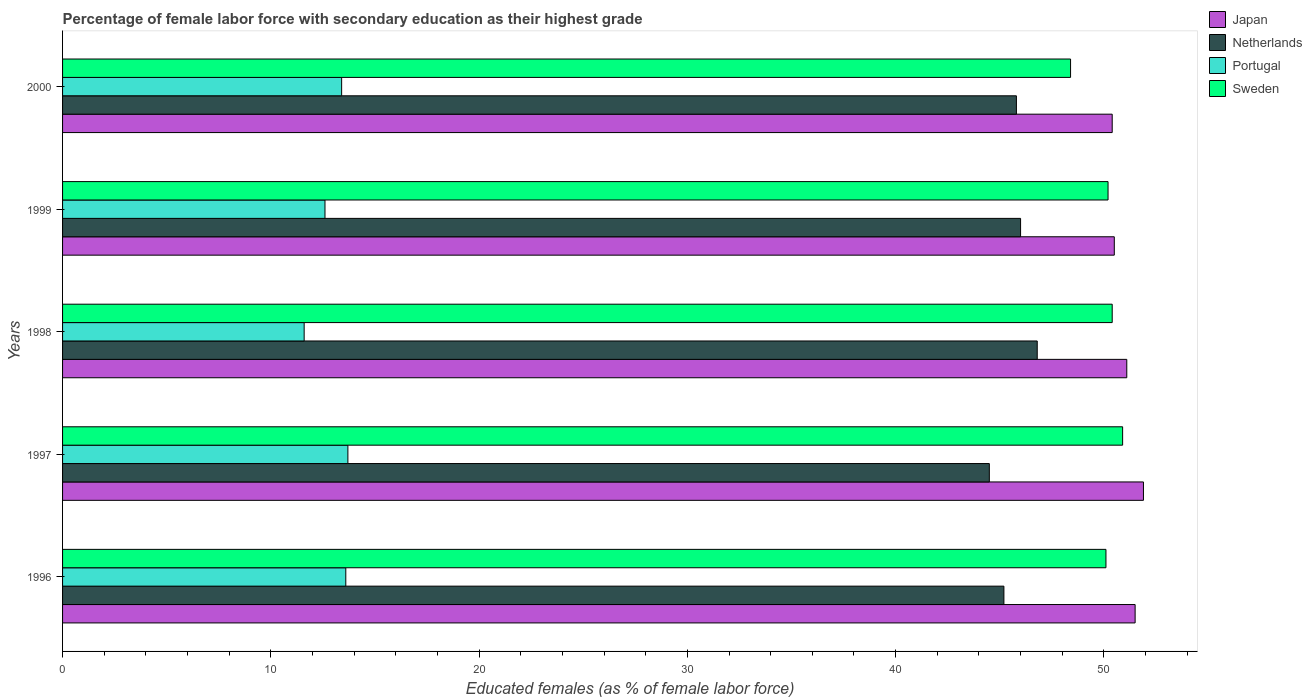How many different coloured bars are there?
Your answer should be very brief. 4. How many groups of bars are there?
Offer a terse response. 5. What is the label of the 4th group of bars from the top?
Your answer should be compact. 1997. What is the percentage of female labor force with secondary education in Sweden in 1998?
Keep it short and to the point. 50.4. Across all years, what is the maximum percentage of female labor force with secondary education in Sweden?
Ensure brevity in your answer.  50.9. Across all years, what is the minimum percentage of female labor force with secondary education in Portugal?
Offer a terse response. 11.6. In which year was the percentage of female labor force with secondary education in Portugal maximum?
Your answer should be compact. 1997. In which year was the percentage of female labor force with secondary education in Portugal minimum?
Make the answer very short. 1998. What is the total percentage of female labor force with secondary education in Japan in the graph?
Your answer should be very brief. 255.4. What is the difference between the percentage of female labor force with secondary education in Netherlands in 1997 and that in 2000?
Offer a terse response. -1.3. What is the difference between the percentage of female labor force with secondary education in Netherlands in 1996 and the percentage of female labor force with secondary education in Sweden in 1999?
Your answer should be compact. -5. What is the average percentage of female labor force with secondary education in Sweden per year?
Keep it short and to the point. 50. In the year 2000, what is the difference between the percentage of female labor force with secondary education in Portugal and percentage of female labor force with secondary education in Sweden?
Ensure brevity in your answer.  -35. In how many years, is the percentage of female labor force with secondary education in Portugal greater than 38 %?
Make the answer very short. 0. What is the ratio of the percentage of female labor force with secondary education in Portugal in 1997 to that in 2000?
Your answer should be compact. 1.02. What is the difference between the highest and the second highest percentage of female labor force with secondary education in Netherlands?
Make the answer very short. 0.8. What is the difference between the highest and the lowest percentage of female labor force with secondary education in Sweden?
Make the answer very short. 2.5. In how many years, is the percentage of female labor force with secondary education in Portugal greater than the average percentage of female labor force with secondary education in Portugal taken over all years?
Your response must be concise. 3. Is it the case that in every year, the sum of the percentage of female labor force with secondary education in Japan and percentage of female labor force with secondary education in Portugal is greater than the sum of percentage of female labor force with secondary education in Sweden and percentage of female labor force with secondary education in Netherlands?
Your answer should be compact. No. Is it the case that in every year, the sum of the percentage of female labor force with secondary education in Portugal and percentage of female labor force with secondary education in Japan is greater than the percentage of female labor force with secondary education in Sweden?
Give a very brief answer. Yes. Are all the bars in the graph horizontal?
Keep it short and to the point. Yes. How many years are there in the graph?
Your response must be concise. 5. Are the values on the major ticks of X-axis written in scientific E-notation?
Your response must be concise. No. Does the graph contain grids?
Your response must be concise. No. How many legend labels are there?
Keep it short and to the point. 4. How are the legend labels stacked?
Provide a succinct answer. Vertical. What is the title of the graph?
Provide a succinct answer. Percentage of female labor force with secondary education as their highest grade. What is the label or title of the X-axis?
Keep it short and to the point. Educated females (as % of female labor force). What is the label or title of the Y-axis?
Offer a terse response. Years. What is the Educated females (as % of female labor force) of Japan in 1996?
Give a very brief answer. 51.5. What is the Educated females (as % of female labor force) of Netherlands in 1996?
Make the answer very short. 45.2. What is the Educated females (as % of female labor force) in Portugal in 1996?
Your response must be concise. 13.6. What is the Educated females (as % of female labor force) in Sweden in 1996?
Offer a terse response. 50.1. What is the Educated females (as % of female labor force) of Japan in 1997?
Give a very brief answer. 51.9. What is the Educated females (as % of female labor force) of Netherlands in 1997?
Give a very brief answer. 44.5. What is the Educated females (as % of female labor force) in Portugal in 1997?
Your answer should be compact. 13.7. What is the Educated females (as % of female labor force) of Sweden in 1997?
Provide a succinct answer. 50.9. What is the Educated females (as % of female labor force) in Japan in 1998?
Provide a succinct answer. 51.1. What is the Educated females (as % of female labor force) in Netherlands in 1998?
Your response must be concise. 46.8. What is the Educated females (as % of female labor force) in Portugal in 1998?
Your response must be concise. 11.6. What is the Educated females (as % of female labor force) of Sweden in 1998?
Make the answer very short. 50.4. What is the Educated females (as % of female labor force) of Japan in 1999?
Keep it short and to the point. 50.5. What is the Educated females (as % of female labor force) of Portugal in 1999?
Your answer should be compact. 12.6. What is the Educated females (as % of female labor force) of Sweden in 1999?
Your answer should be very brief. 50.2. What is the Educated females (as % of female labor force) of Japan in 2000?
Your response must be concise. 50.4. What is the Educated females (as % of female labor force) of Netherlands in 2000?
Ensure brevity in your answer.  45.8. What is the Educated females (as % of female labor force) in Portugal in 2000?
Make the answer very short. 13.4. What is the Educated females (as % of female labor force) in Sweden in 2000?
Your answer should be compact. 48.4. Across all years, what is the maximum Educated females (as % of female labor force) in Japan?
Offer a terse response. 51.9. Across all years, what is the maximum Educated females (as % of female labor force) of Netherlands?
Provide a short and direct response. 46.8. Across all years, what is the maximum Educated females (as % of female labor force) of Portugal?
Offer a very short reply. 13.7. Across all years, what is the maximum Educated females (as % of female labor force) of Sweden?
Make the answer very short. 50.9. Across all years, what is the minimum Educated females (as % of female labor force) of Japan?
Your response must be concise. 50.4. Across all years, what is the minimum Educated females (as % of female labor force) in Netherlands?
Ensure brevity in your answer.  44.5. Across all years, what is the minimum Educated females (as % of female labor force) of Portugal?
Offer a very short reply. 11.6. Across all years, what is the minimum Educated females (as % of female labor force) of Sweden?
Offer a very short reply. 48.4. What is the total Educated females (as % of female labor force) of Japan in the graph?
Give a very brief answer. 255.4. What is the total Educated females (as % of female labor force) of Netherlands in the graph?
Your answer should be very brief. 228.3. What is the total Educated females (as % of female labor force) of Portugal in the graph?
Offer a very short reply. 64.9. What is the total Educated females (as % of female labor force) in Sweden in the graph?
Ensure brevity in your answer.  250. What is the difference between the Educated females (as % of female labor force) in Japan in 1996 and that in 1997?
Keep it short and to the point. -0.4. What is the difference between the Educated females (as % of female labor force) of Netherlands in 1996 and that in 1997?
Make the answer very short. 0.7. What is the difference between the Educated females (as % of female labor force) in Sweden in 1996 and that in 1997?
Give a very brief answer. -0.8. What is the difference between the Educated females (as % of female labor force) of Netherlands in 1996 and that in 1998?
Provide a succinct answer. -1.6. What is the difference between the Educated females (as % of female labor force) in Portugal in 1996 and that in 1998?
Your response must be concise. 2. What is the difference between the Educated females (as % of female labor force) in Sweden in 1996 and that in 1998?
Offer a very short reply. -0.3. What is the difference between the Educated females (as % of female labor force) in Netherlands in 1996 and that in 1999?
Offer a terse response. -0.8. What is the difference between the Educated females (as % of female labor force) of Portugal in 1996 and that in 2000?
Your answer should be compact. 0.2. What is the difference between the Educated females (as % of female labor force) in Sweden in 1996 and that in 2000?
Your answer should be very brief. 1.7. What is the difference between the Educated females (as % of female labor force) in Japan in 1997 and that in 1998?
Your answer should be very brief. 0.8. What is the difference between the Educated females (as % of female labor force) of Netherlands in 1997 and that in 1998?
Provide a succinct answer. -2.3. What is the difference between the Educated females (as % of female labor force) in Portugal in 1997 and that in 1998?
Keep it short and to the point. 2.1. What is the difference between the Educated females (as % of female labor force) in Japan in 1997 and that in 1999?
Ensure brevity in your answer.  1.4. What is the difference between the Educated females (as % of female labor force) of Netherlands in 1997 and that in 1999?
Offer a terse response. -1.5. What is the difference between the Educated females (as % of female labor force) of Portugal in 1997 and that in 1999?
Your answer should be compact. 1.1. What is the difference between the Educated females (as % of female labor force) of Sweden in 1997 and that in 1999?
Offer a terse response. 0.7. What is the difference between the Educated females (as % of female labor force) in Netherlands in 1997 and that in 2000?
Make the answer very short. -1.3. What is the difference between the Educated females (as % of female labor force) of Netherlands in 1998 and that in 1999?
Your response must be concise. 0.8. What is the difference between the Educated females (as % of female labor force) of Japan in 1998 and that in 2000?
Your response must be concise. 0.7. What is the difference between the Educated females (as % of female labor force) in Portugal in 1998 and that in 2000?
Your answer should be compact. -1.8. What is the difference between the Educated females (as % of female labor force) in Sweden in 1998 and that in 2000?
Offer a terse response. 2. What is the difference between the Educated females (as % of female labor force) of Netherlands in 1999 and that in 2000?
Your answer should be very brief. 0.2. What is the difference between the Educated females (as % of female labor force) of Japan in 1996 and the Educated females (as % of female labor force) of Portugal in 1997?
Your answer should be compact. 37.8. What is the difference between the Educated females (as % of female labor force) of Netherlands in 1996 and the Educated females (as % of female labor force) of Portugal in 1997?
Keep it short and to the point. 31.5. What is the difference between the Educated females (as % of female labor force) of Netherlands in 1996 and the Educated females (as % of female labor force) of Sweden in 1997?
Offer a very short reply. -5.7. What is the difference between the Educated females (as % of female labor force) of Portugal in 1996 and the Educated females (as % of female labor force) of Sweden in 1997?
Keep it short and to the point. -37.3. What is the difference between the Educated females (as % of female labor force) in Japan in 1996 and the Educated females (as % of female labor force) in Portugal in 1998?
Keep it short and to the point. 39.9. What is the difference between the Educated females (as % of female labor force) in Netherlands in 1996 and the Educated females (as % of female labor force) in Portugal in 1998?
Offer a very short reply. 33.6. What is the difference between the Educated females (as % of female labor force) in Portugal in 1996 and the Educated females (as % of female labor force) in Sweden in 1998?
Your answer should be very brief. -36.8. What is the difference between the Educated females (as % of female labor force) in Japan in 1996 and the Educated females (as % of female labor force) in Portugal in 1999?
Offer a terse response. 38.9. What is the difference between the Educated females (as % of female labor force) of Japan in 1996 and the Educated females (as % of female labor force) of Sweden in 1999?
Offer a very short reply. 1.3. What is the difference between the Educated females (as % of female labor force) of Netherlands in 1996 and the Educated females (as % of female labor force) of Portugal in 1999?
Keep it short and to the point. 32.6. What is the difference between the Educated females (as % of female labor force) of Portugal in 1996 and the Educated females (as % of female labor force) of Sweden in 1999?
Give a very brief answer. -36.6. What is the difference between the Educated females (as % of female labor force) of Japan in 1996 and the Educated females (as % of female labor force) of Netherlands in 2000?
Offer a very short reply. 5.7. What is the difference between the Educated females (as % of female labor force) of Japan in 1996 and the Educated females (as % of female labor force) of Portugal in 2000?
Your response must be concise. 38.1. What is the difference between the Educated females (as % of female labor force) of Netherlands in 1996 and the Educated females (as % of female labor force) of Portugal in 2000?
Offer a terse response. 31.8. What is the difference between the Educated females (as % of female labor force) of Netherlands in 1996 and the Educated females (as % of female labor force) of Sweden in 2000?
Your answer should be very brief. -3.2. What is the difference between the Educated females (as % of female labor force) in Portugal in 1996 and the Educated females (as % of female labor force) in Sweden in 2000?
Offer a very short reply. -34.8. What is the difference between the Educated females (as % of female labor force) of Japan in 1997 and the Educated females (as % of female labor force) of Netherlands in 1998?
Provide a short and direct response. 5.1. What is the difference between the Educated females (as % of female labor force) of Japan in 1997 and the Educated females (as % of female labor force) of Portugal in 1998?
Keep it short and to the point. 40.3. What is the difference between the Educated females (as % of female labor force) in Japan in 1997 and the Educated females (as % of female labor force) in Sweden in 1998?
Your answer should be compact. 1.5. What is the difference between the Educated females (as % of female labor force) of Netherlands in 1997 and the Educated females (as % of female labor force) of Portugal in 1998?
Ensure brevity in your answer.  32.9. What is the difference between the Educated females (as % of female labor force) of Portugal in 1997 and the Educated females (as % of female labor force) of Sweden in 1998?
Keep it short and to the point. -36.7. What is the difference between the Educated females (as % of female labor force) in Japan in 1997 and the Educated females (as % of female labor force) in Netherlands in 1999?
Provide a short and direct response. 5.9. What is the difference between the Educated females (as % of female labor force) of Japan in 1997 and the Educated females (as % of female labor force) of Portugal in 1999?
Offer a very short reply. 39.3. What is the difference between the Educated females (as % of female labor force) of Netherlands in 1997 and the Educated females (as % of female labor force) of Portugal in 1999?
Offer a very short reply. 31.9. What is the difference between the Educated females (as % of female labor force) of Netherlands in 1997 and the Educated females (as % of female labor force) of Sweden in 1999?
Keep it short and to the point. -5.7. What is the difference between the Educated females (as % of female labor force) of Portugal in 1997 and the Educated females (as % of female labor force) of Sweden in 1999?
Provide a succinct answer. -36.5. What is the difference between the Educated females (as % of female labor force) in Japan in 1997 and the Educated females (as % of female labor force) in Portugal in 2000?
Your response must be concise. 38.5. What is the difference between the Educated females (as % of female labor force) in Netherlands in 1997 and the Educated females (as % of female labor force) in Portugal in 2000?
Provide a succinct answer. 31.1. What is the difference between the Educated females (as % of female labor force) of Portugal in 1997 and the Educated females (as % of female labor force) of Sweden in 2000?
Your answer should be compact. -34.7. What is the difference between the Educated females (as % of female labor force) of Japan in 1998 and the Educated females (as % of female labor force) of Netherlands in 1999?
Offer a very short reply. 5.1. What is the difference between the Educated females (as % of female labor force) of Japan in 1998 and the Educated females (as % of female labor force) of Portugal in 1999?
Make the answer very short. 38.5. What is the difference between the Educated females (as % of female labor force) of Netherlands in 1998 and the Educated females (as % of female labor force) of Portugal in 1999?
Ensure brevity in your answer.  34.2. What is the difference between the Educated females (as % of female labor force) of Portugal in 1998 and the Educated females (as % of female labor force) of Sweden in 1999?
Offer a very short reply. -38.6. What is the difference between the Educated females (as % of female labor force) in Japan in 1998 and the Educated females (as % of female labor force) in Portugal in 2000?
Keep it short and to the point. 37.7. What is the difference between the Educated females (as % of female labor force) of Netherlands in 1998 and the Educated females (as % of female labor force) of Portugal in 2000?
Offer a very short reply. 33.4. What is the difference between the Educated females (as % of female labor force) of Portugal in 1998 and the Educated females (as % of female labor force) of Sweden in 2000?
Give a very brief answer. -36.8. What is the difference between the Educated females (as % of female labor force) in Japan in 1999 and the Educated females (as % of female labor force) in Netherlands in 2000?
Provide a short and direct response. 4.7. What is the difference between the Educated females (as % of female labor force) in Japan in 1999 and the Educated females (as % of female labor force) in Portugal in 2000?
Provide a short and direct response. 37.1. What is the difference between the Educated females (as % of female labor force) of Japan in 1999 and the Educated females (as % of female labor force) of Sweden in 2000?
Provide a short and direct response. 2.1. What is the difference between the Educated females (as % of female labor force) in Netherlands in 1999 and the Educated females (as % of female labor force) in Portugal in 2000?
Keep it short and to the point. 32.6. What is the difference between the Educated females (as % of female labor force) in Portugal in 1999 and the Educated females (as % of female labor force) in Sweden in 2000?
Give a very brief answer. -35.8. What is the average Educated females (as % of female labor force) of Japan per year?
Provide a short and direct response. 51.08. What is the average Educated females (as % of female labor force) of Netherlands per year?
Your answer should be very brief. 45.66. What is the average Educated females (as % of female labor force) in Portugal per year?
Your answer should be compact. 12.98. What is the average Educated females (as % of female labor force) of Sweden per year?
Offer a terse response. 50. In the year 1996, what is the difference between the Educated females (as % of female labor force) of Japan and Educated females (as % of female labor force) of Portugal?
Make the answer very short. 37.9. In the year 1996, what is the difference between the Educated females (as % of female labor force) of Japan and Educated females (as % of female labor force) of Sweden?
Your answer should be very brief. 1.4. In the year 1996, what is the difference between the Educated females (as % of female labor force) in Netherlands and Educated females (as % of female labor force) in Portugal?
Ensure brevity in your answer.  31.6. In the year 1996, what is the difference between the Educated females (as % of female labor force) in Netherlands and Educated females (as % of female labor force) in Sweden?
Make the answer very short. -4.9. In the year 1996, what is the difference between the Educated females (as % of female labor force) in Portugal and Educated females (as % of female labor force) in Sweden?
Provide a short and direct response. -36.5. In the year 1997, what is the difference between the Educated females (as % of female labor force) of Japan and Educated females (as % of female labor force) of Portugal?
Provide a short and direct response. 38.2. In the year 1997, what is the difference between the Educated females (as % of female labor force) of Netherlands and Educated females (as % of female labor force) of Portugal?
Keep it short and to the point. 30.8. In the year 1997, what is the difference between the Educated females (as % of female labor force) of Portugal and Educated females (as % of female labor force) of Sweden?
Offer a very short reply. -37.2. In the year 1998, what is the difference between the Educated females (as % of female labor force) of Japan and Educated females (as % of female labor force) of Netherlands?
Your answer should be compact. 4.3. In the year 1998, what is the difference between the Educated females (as % of female labor force) of Japan and Educated females (as % of female labor force) of Portugal?
Offer a terse response. 39.5. In the year 1998, what is the difference between the Educated females (as % of female labor force) in Netherlands and Educated females (as % of female labor force) in Portugal?
Offer a terse response. 35.2. In the year 1998, what is the difference between the Educated females (as % of female labor force) in Portugal and Educated females (as % of female labor force) in Sweden?
Your answer should be compact. -38.8. In the year 1999, what is the difference between the Educated females (as % of female labor force) in Japan and Educated females (as % of female labor force) in Netherlands?
Provide a short and direct response. 4.5. In the year 1999, what is the difference between the Educated females (as % of female labor force) of Japan and Educated females (as % of female labor force) of Portugal?
Your response must be concise. 37.9. In the year 1999, what is the difference between the Educated females (as % of female labor force) of Japan and Educated females (as % of female labor force) of Sweden?
Your answer should be very brief. 0.3. In the year 1999, what is the difference between the Educated females (as % of female labor force) of Netherlands and Educated females (as % of female labor force) of Portugal?
Offer a terse response. 33.4. In the year 1999, what is the difference between the Educated females (as % of female labor force) in Netherlands and Educated females (as % of female labor force) in Sweden?
Offer a terse response. -4.2. In the year 1999, what is the difference between the Educated females (as % of female labor force) of Portugal and Educated females (as % of female labor force) of Sweden?
Keep it short and to the point. -37.6. In the year 2000, what is the difference between the Educated females (as % of female labor force) of Japan and Educated females (as % of female labor force) of Netherlands?
Your answer should be very brief. 4.6. In the year 2000, what is the difference between the Educated females (as % of female labor force) in Japan and Educated females (as % of female labor force) in Portugal?
Provide a short and direct response. 37. In the year 2000, what is the difference between the Educated females (as % of female labor force) in Japan and Educated females (as % of female labor force) in Sweden?
Offer a terse response. 2. In the year 2000, what is the difference between the Educated females (as % of female labor force) in Netherlands and Educated females (as % of female labor force) in Portugal?
Offer a terse response. 32.4. In the year 2000, what is the difference between the Educated females (as % of female labor force) in Netherlands and Educated females (as % of female labor force) in Sweden?
Provide a short and direct response. -2.6. In the year 2000, what is the difference between the Educated females (as % of female labor force) in Portugal and Educated females (as % of female labor force) in Sweden?
Your answer should be very brief. -35. What is the ratio of the Educated females (as % of female labor force) in Japan in 1996 to that in 1997?
Your response must be concise. 0.99. What is the ratio of the Educated females (as % of female labor force) of Netherlands in 1996 to that in 1997?
Provide a short and direct response. 1.02. What is the ratio of the Educated females (as % of female labor force) in Sweden in 1996 to that in 1997?
Give a very brief answer. 0.98. What is the ratio of the Educated females (as % of female labor force) in Netherlands in 1996 to that in 1998?
Make the answer very short. 0.97. What is the ratio of the Educated females (as % of female labor force) in Portugal in 1996 to that in 1998?
Your answer should be compact. 1.17. What is the ratio of the Educated females (as % of female labor force) in Japan in 1996 to that in 1999?
Your answer should be compact. 1.02. What is the ratio of the Educated females (as % of female labor force) of Netherlands in 1996 to that in 1999?
Ensure brevity in your answer.  0.98. What is the ratio of the Educated females (as % of female labor force) in Portugal in 1996 to that in 1999?
Ensure brevity in your answer.  1.08. What is the ratio of the Educated females (as % of female labor force) of Japan in 1996 to that in 2000?
Provide a succinct answer. 1.02. What is the ratio of the Educated females (as % of female labor force) of Netherlands in 1996 to that in 2000?
Provide a short and direct response. 0.99. What is the ratio of the Educated females (as % of female labor force) of Portugal in 1996 to that in 2000?
Make the answer very short. 1.01. What is the ratio of the Educated females (as % of female labor force) of Sweden in 1996 to that in 2000?
Offer a very short reply. 1.04. What is the ratio of the Educated females (as % of female labor force) in Japan in 1997 to that in 1998?
Offer a terse response. 1.02. What is the ratio of the Educated females (as % of female labor force) in Netherlands in 1997 to that in 1998?
Your answer should be very brief. 0.95. What is the ratio of the Educated females (as % of female labor force) in Portugal in 1997 to that in 1998?
Make the answer very short. 1.18. What is the ratio of the Educated females (as % of female labor force) in Sweden in 1997 to that in 1998?
Keep it short and to the point. 1.01. What is the ratio of the Educated females (as % of female labor force) of Japan in 1997 to that in 1999?
Make the answer very short. 1.03. What is the ratio of the Educated females (as % of female labor force) in Netherlands in 1997 to that in 1999?
Your response must be concise. 0.97. What is the ratio of the Educated females (as % of female labor force) of Portugal in 1997 to that in 1999?
Your answer should be compact. 1.09. What is the ratio of the Educated females (as % of female labor force) in Sweden in 1997 to that in 1999?
Your answer should be compact. 1.01. What is the ratio of the Educated females (as % of female labor force) in Japan in 1997 to that in 2000?
Your response must be concise. 1.03. What is the ratio of the Educated females (as % of female labor force) of Netherlands in 1997 to that in 2000?
Offer a terse response. 0.97. What is the ratio of the Educated females (as % of female labor force) in Portugal in 1997 to that in 2000?
Provide a short and direct response. 1.02. What is the ratio of the Educated females (as % of female labor force) in Sweden in 1997 to that in 2000?
Keep it short and to the point. 1.05. What is the ratio of the Educated females (as % of female labor force) of Japan in 1998 to that in 1999?
Provide a succinct answer. 1.01. What is the ratio of the Educated females (as % of female labor force) of Netherlands in 1998 to that in 1999?
Your response must be concise. 1.02. What is the ratio of the Educated females (as % of female labor force) of Portugal in 1998 to that in 1999?
Offer a terse response. 0.92. What is the ratio of the Educated females (as % of female labor force) in Sweden in 1998 to that in 1999?
Your answer should be compact. 1. What is the ratio of the Educated females (as % of female labor force) of Japan in 1998 to that in 2000?
Offer a very short reply. 1.01. What is the ratio of the Educated females (as % of female labor force) in Netherlands in 1998 to that in 2000?
Your answer should be compact. 1.02. What is the ratio of the Educated females (as % of female labor force) of Portugal in 1998 to that in 2000?
Make the answer very short. 0.87. What is the ratio of the Educated females (as % of female labor force) of Sweden in 1998 to that in 2000?
Provide a succinct answer. 1.04. What is the ratio of the Educated females (as % of female labor force) of Japan in 1999 to that in 2000?
Ensure brevity in your answer.  1. What is the ratio of the Educated females (as % of female labor force) in Netherlands in 1999 to that in 2000?
Keep it short and to the point. 1. What is the ratio of the Educated females (as % of female labor force) of Portugal in 1999 to that in 2000?
Your answer should be very brief. 0.94. What is the ratio of the Educated females (as % of female labor force) in Sweden in 1999 to that in 2000?
Provide a short and direct response. 1.04. What is the difference between the highest and the second highest Educated females (as % of female labor force) of Portugal?
Provide a short and direct response. 0.1. What is the difference between the highest and the lowest Educated females (as % of female labor force) in Portugal?
Make the answer very short. 2.1. 